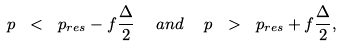Convert formula to latex. <formula><loc_0><loc_0><loc_500><loc_500>p \ < \ p _ { r e s } - f { \frac { \Delta } { 2 } } \ \ a n d \ \ p \ > \ p _ { r e s } + f { \frac { \Delta } { 2 } } ,</formula> 